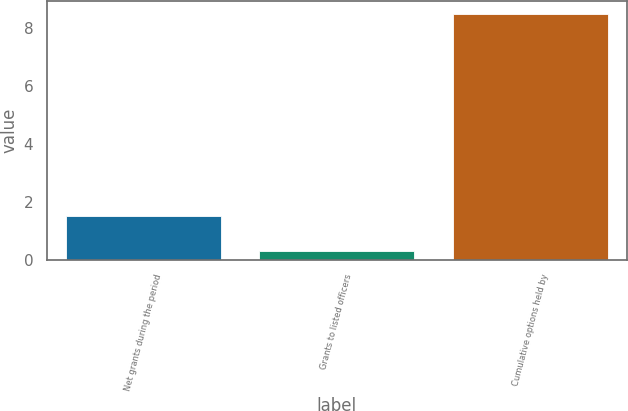Convert chart. <chart><loc_0><loc_0><loc_500><loc_500><bar_chart><fcel>Net grants during the period<fcel>Grants to listed officers<fcel>Cumulative options held by<nl><fcel>1.5<fcel>0.3<fcel>8.5<nl></chart> 